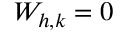Convert formula to latex. <formula><loc_0><loc_0><loc_500><loc_500>W _ { h , k } = 0</formula> 